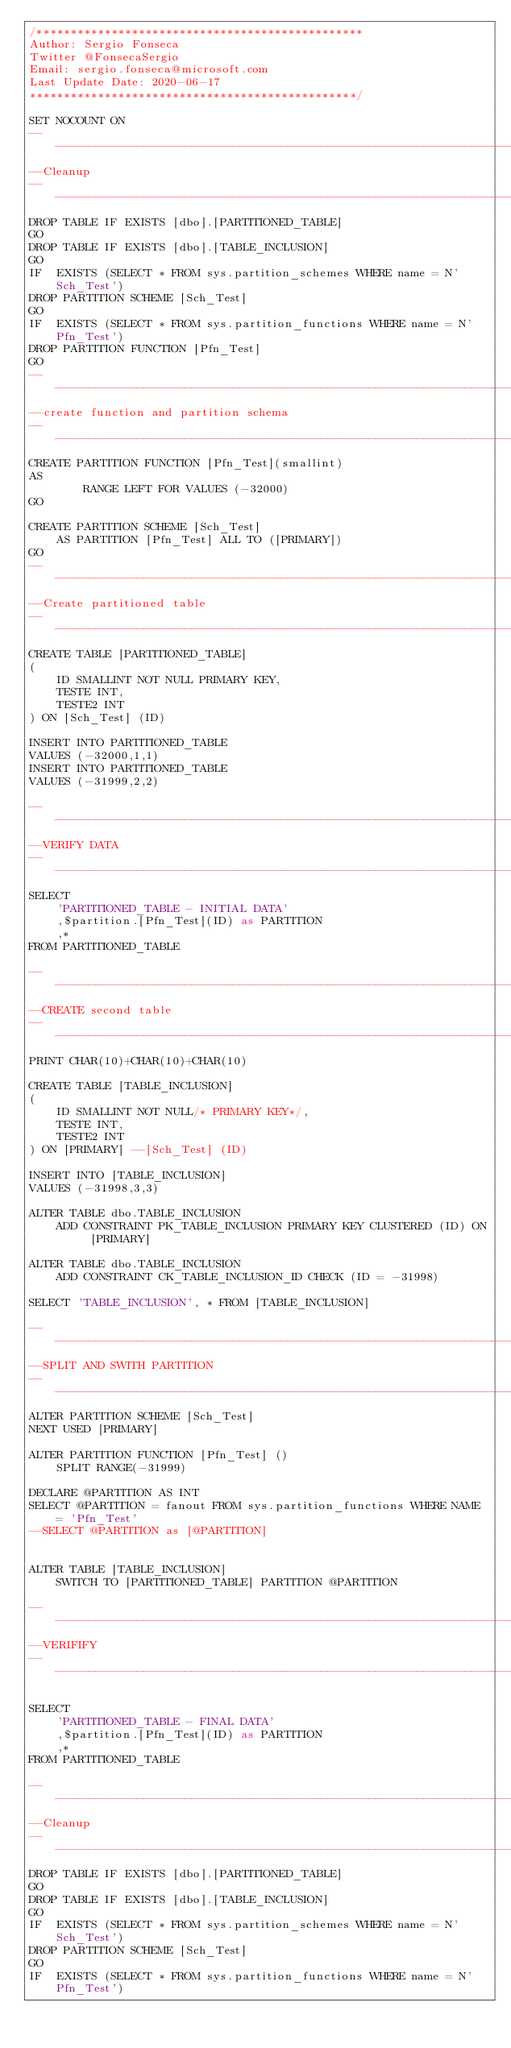<code> <loc_0><loc_0><loc_500><loc_500><_SQL_>/************************************************
Author: Sergio Fonseca
Twitter @FonsecaSergio
Email: sergio.fonseca@microsoft.com
Last Update Date: 2020-06-17
************************************************/

SET NOCOUNT ON
----------------------------------------------------------------------------------------------------------------------------------------------------------
--Cleanup
----------------------------------------------------------------------------------------------------------------------------------------------------------
DROP TABLE IF EXISTS [dbo].[PARTITIONED_TABLE]
GO
DROP TABLE IF EXISTS [dbo].[TABLE_INCLUSION]
GO
IF  EXISTS (SELECT * FROM sys.partition_schemes WHERE name = N'Sch_Test')
DROP PARTITION SCHEME [Sch_Test]
GO
IF  EXISTS (SELECT * FROM sys.partition_functions WHERE name = N'Pfn_Test')
DROP PARTITION FUNCTION [Pfn_Test]
GO
----------------------------------------------------------------------------------------------------------------------------------------------------------
--create function and partition schema
----------------------------------------------------------------------------------------------------------------------------------------------------------
CREATE PARTITION FUNCTION [Pfn_Test](smallint) 
AS 
		RANGE LEFT FOR VALUES (-32000)
GO

CREATE PARTITION SCHEME [Sch_Test] 
	AS PARTITION [Pfn_Test] ALL TO ([PRIMARY])
GO
----------------------------------------------------------------------------------------------------------------------------------------------------------
--Create partitioned table
----------------------------------------------------------------------------------------------------------------------------------------------------------
CREATE TABLE [PARTITIONED_TABLE]
(
	ID SMALLINT NOT NULL PRIMARY KEY,
	TESTE INT,
	TESTE2 INT
) ON [Sch_Test] (ID)

INSERT INTO PARTITIONED_TABLE
VALUES (-32000,1,1)
INSERT INTO PARTITIONED_TABLE
VALUES (-31999,2,2)

----------------------------------------------------------------------------------------------------------------------------------------------------------
--VERIFY DATA
----------------------------------------------------------------------------------------------------------------------------------------------------------
SELECT 
	'PARTITIONED_TABLE - INITIAL DATA'
	,$partition.[Pfn_Test](ID) as PARTITION
	,* 
FROM PARTITIONED_TABLE

----------------------------------------------------------------------------------------------------------------------------------------------------------
--CREATE second table
----------------------------------------------------------------------------------------------------------------------------------------------------------
PRINT CHAR(10)+CHAR(10)+CHAR(10)

CREATE TABLE [TABLE_INCLUSION]
(
	ID SMALLINT NOT NULL/* PRIMARY KEY*/,
	TESTE INT,
	TESTE2 INT
) ON [PRIMARY] --[Sch_Test] (ID)

INSERT INTO [TABLE_INCLUSION]
VALUES (-31998,3,3)

ALTER TABLE dbo.TABLE_INCLUSION 
	ADD CONSTRAINT PK_TABLE_INCLUSION PRIMARY KEY CLUSTERED (ID) ON [PRIMARY]

ALTER TABLE dbo.TABLE_INCLUSION 
	ADD CONSTRAINT CK_TABLE_INCLUSION_ID CHECK (ID = -31998)

SELECT 'TABLE_INCLUSION', * FROM [TABLE_INCLUSION]

----------------------------------------------------------------------------------------------------------------------------------------------------------
--SPLIT AND SWITH PARTITION
----------------------------------------------------------------------------------------------------------------------------------------------------------
ALTER PARTITION SCHEME [Sch_Test]
NEXT USED [PRIMARY]

ALTER PARTITION FUNCTION [Pfn_Test] ()
	SPLIT RANGE(-31999)

DECLARE @PARTITION AS INT
SELECT @PARTITION = fanout FROM sys.partition_functions WHERE NAME = 'Pfn_Test'
--SELECT @PARTITION as [@PARTITION]


ALTER TABLE [TABLE_INCLUSION]
	SWITCH TO [PARTITIONED_TABLE] PARTITION @PARTITION

----------------------------------------------------------------------------------------------------------------------------------------------------------
--VERIFIFY
----------------------------------------------------------------------------------------------------------------------------------------------------------

SELECT 
	'PARTITIONED_TABLE - FINAL DATA'
	,$partition.[Pfn_Test](ID) as PARTITION
	,* 
FROM PARTITIONED_TABLE

----------------------------------------------------------------------------------------------------------------------------------------------------------
--Cleanup
----------------------------------------------------------------------------------------------------------------------------------------------------------
DROP TABLE IF EXISTS [dbo].[PARTITIONED_TABLE]
GO
DROP TABLE IF EXISTS [dbo].[TABLE_INCLUSION]
GO
IF  EXISTS (SELECT * FROM sys.partition_schemes WHERE name = N'Sch_Test')
DROP PARTITION SCHEME [Sch_Test]
GO
IF  EXISTS (SELECT * FROM sys.partition_functions WHERE name = N'Pfn_Test')</code> 